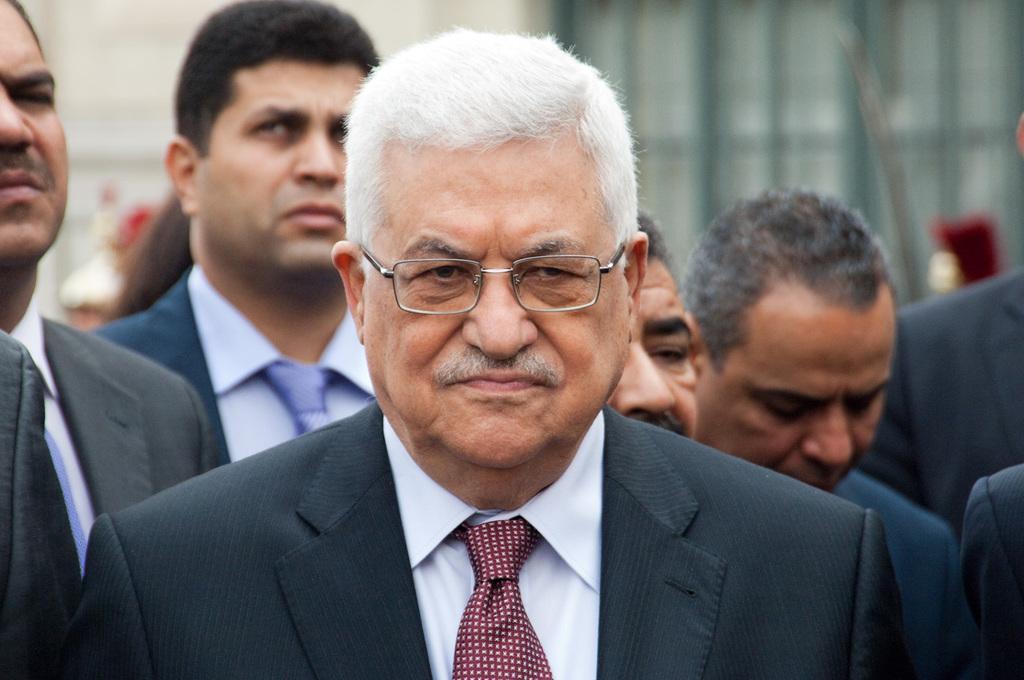Describe this image in one or two sentences. At the bottom of this image, there is a person in a suit and wearing a spectacle. In the background, there are other persons. And the background is blurred. 